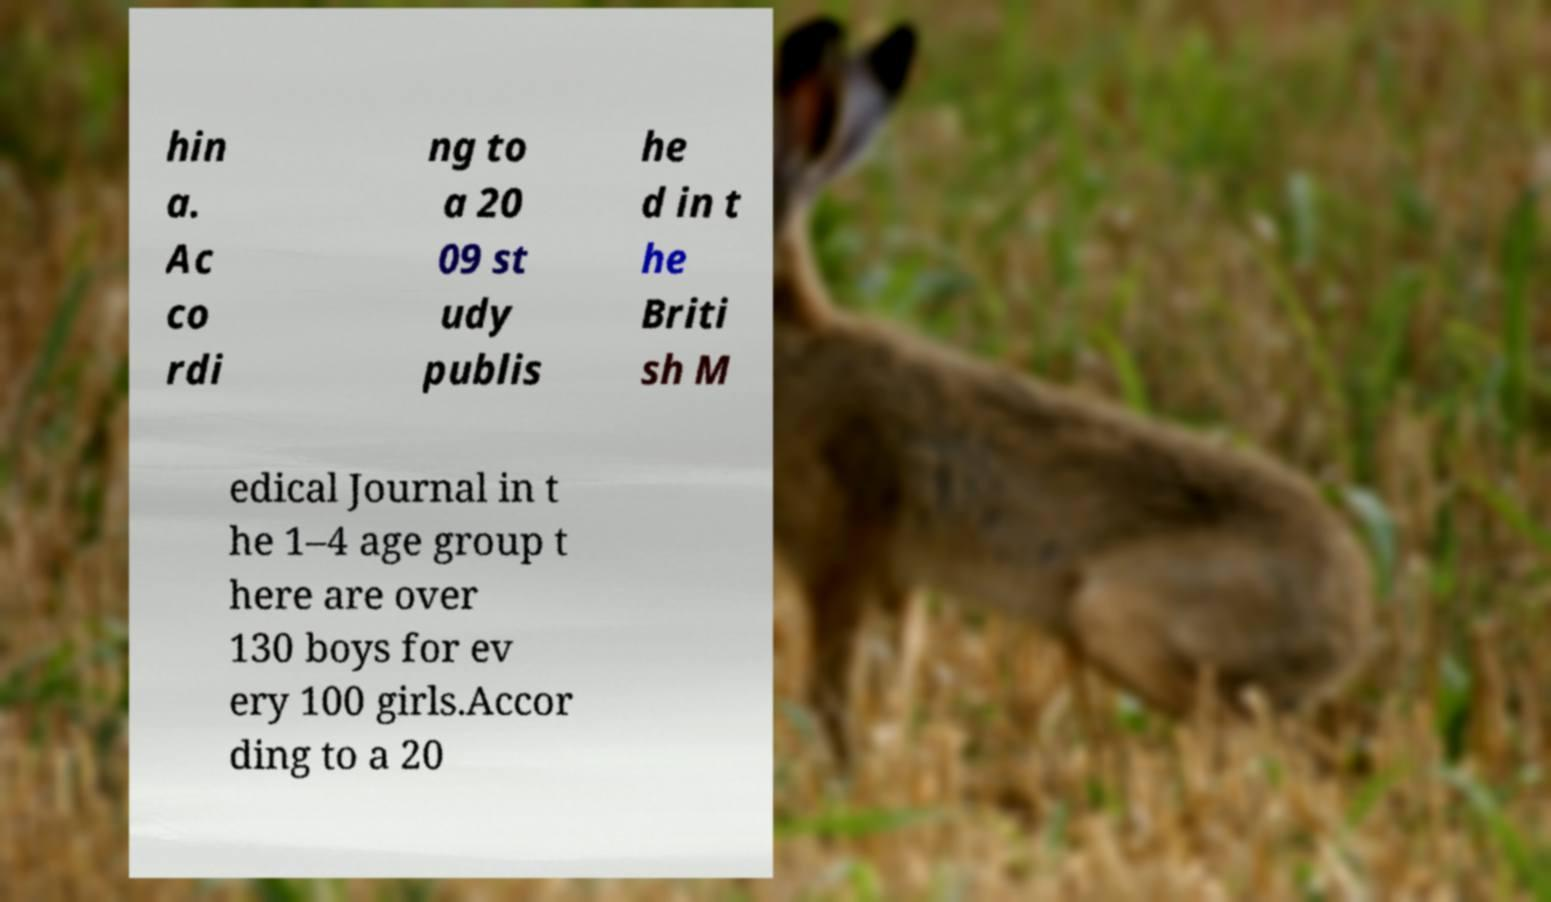Please read and relay the text visible in this image. What does it say? hin a. Ac co rdi ng to a 20 09 st udy publis he d in t he Briti sh M edical Journal in t he 1–4 age group t here are over 130 boys for ev ery 100 girls.Accor ding to a 20 